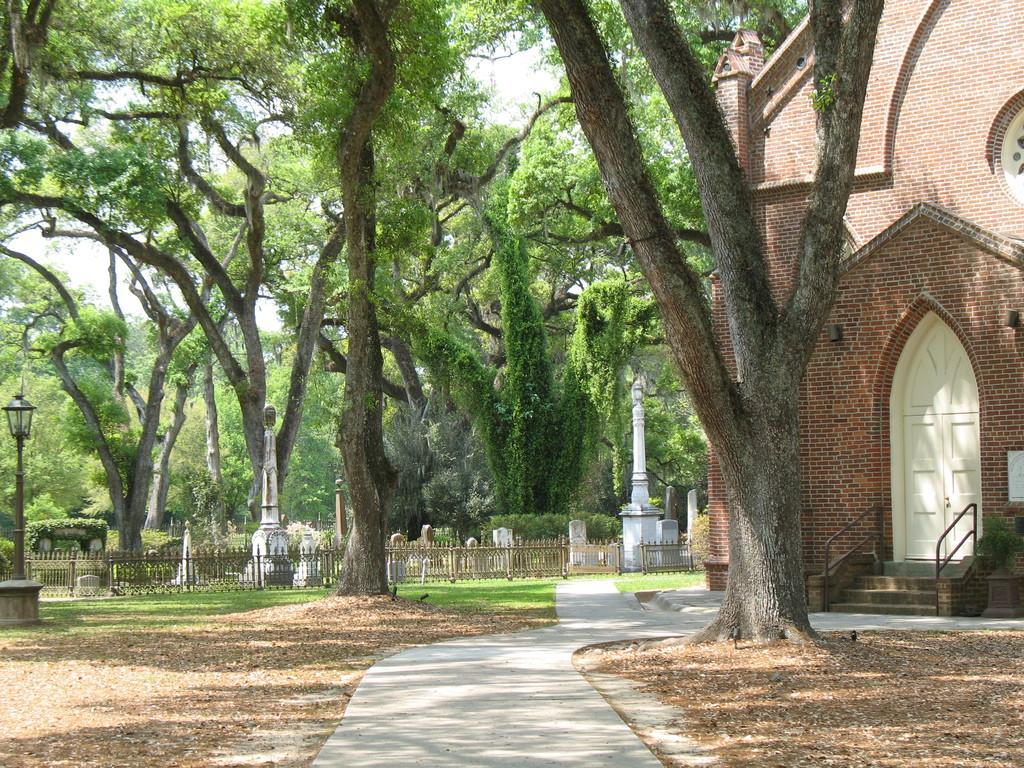Can you describe this image briefly? In this image in the center there is a road and we can see grass on the surface. On the left side of the image there is a light. At the right side of the image there is a building and in front of the building there are stairs. In the background there are trees and graveyard. 